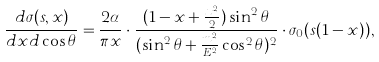Convert formula to latex. <formula><loc_0><loc_0><loc_500><loc_500>\frac { d \sigma ( s , x ) } { d x d \cos { \theta } } = \frac { 2 \alpha } { \pi x } \cdot \frac { ( 1 - x + \frac { x ^ { 2 } } { 2 } ) \sin ^ { 2 } { \theta } } { ( \sin ^ { 2 } { \theta } + \frac { m _ { e } ^ { 2 } } { E ^ { 2 } } \cos ^ { 2 } { \theta } ) ^ { 2 } } \cdot \sigma _ { 0 } ( s ( 1 - x ) ) ,</formula> 